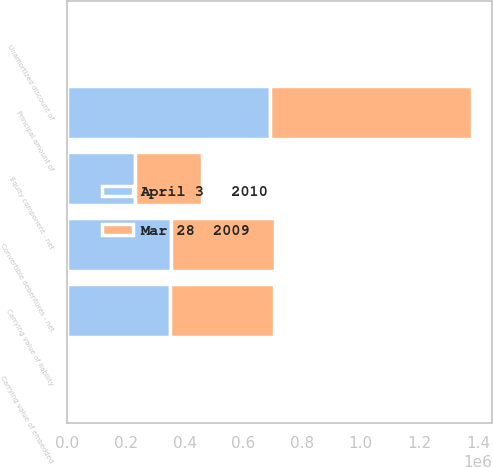Convert chart to OTSL. <chart><loc_0><loc_0><loc_500><loc_500><stacked_bar_chart><ecel><fcel>Principal amount of<fcel>Unamortized discount of<fcel>Carrying value of liability<fcel>Carrying value of embedded<fcel>Convertible debentures - net<fcel>Equity component - net<nl><fcel>Mar 28  2009<fcel>689635<fcel>1562<fcel>353950<fcel>848<fcel>354798<fcel>229513<nl><fcel>April 3   2010<fcel>689635<fcel>1620<fcel>350000<fcel>2110<fcel>352110<fcel>229513<nl></chart> 